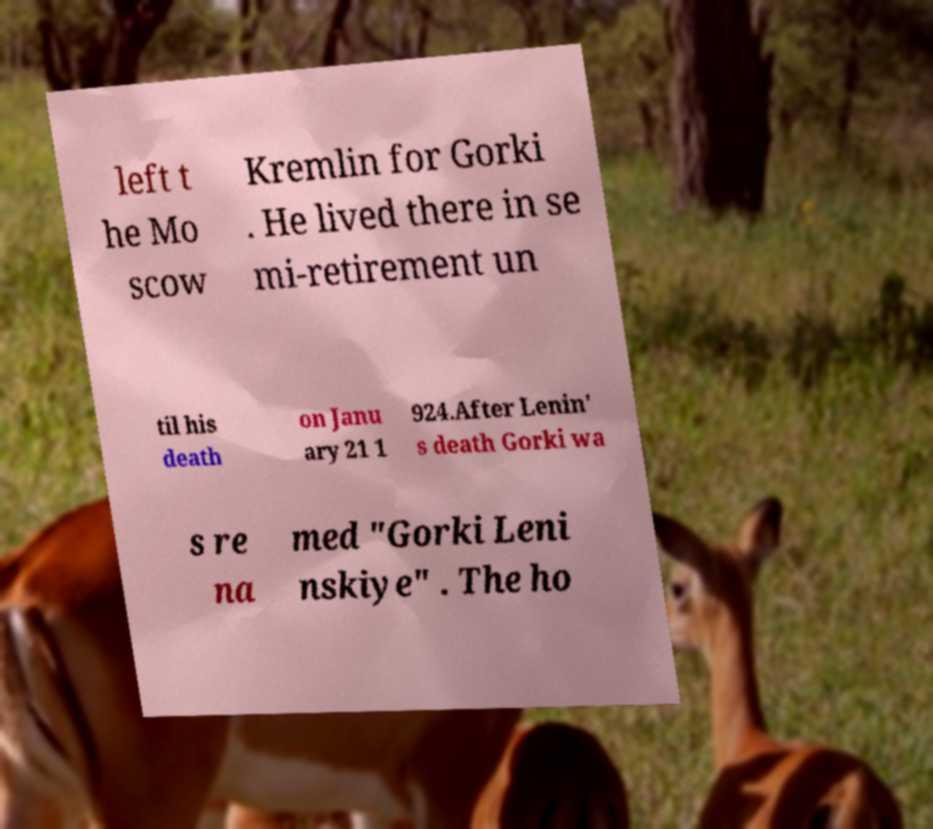I need the written content from this picture converted into text. Can you do that? left t he Mo scow Kremlin for Gorki . He lived there in se mi-retirement un til his death on Janu ary 21 1 924.After Lenin' s death Gorki wa s re na med "Gorki Leni nskiye" . The ho 